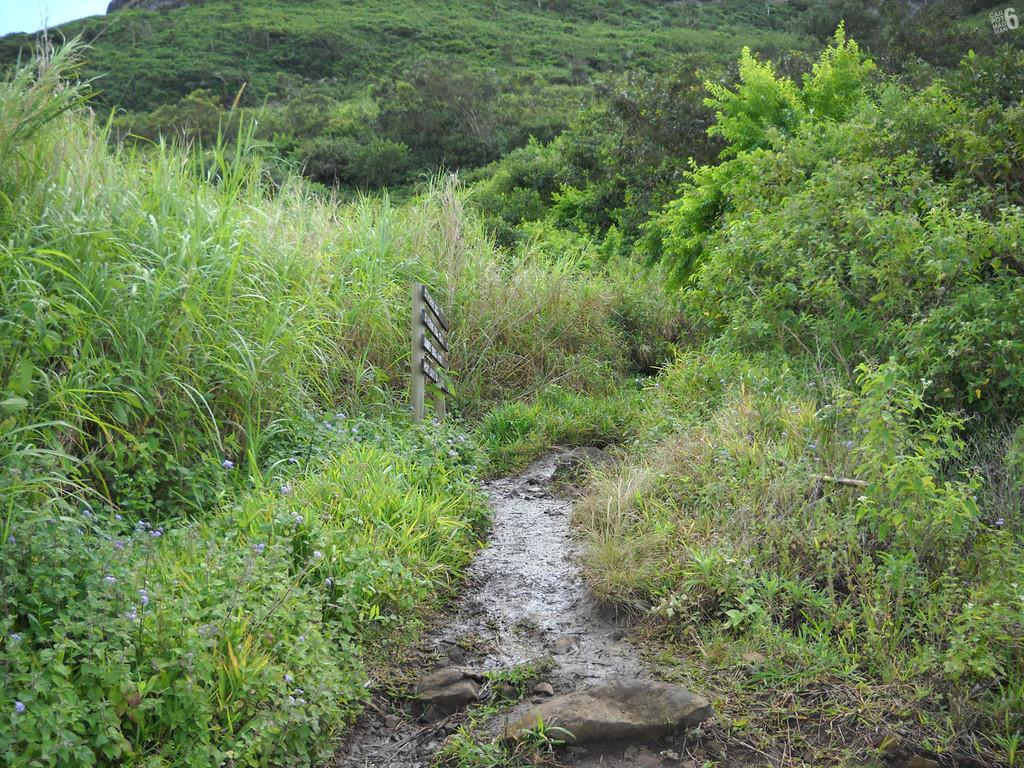What type of vegetation can be seen in the image? There are plants, grass, and trees in the image. What type of ground surface is visible in the image? Stones are present in the image. What structures are on poles in the image? Boards are on poles in the image. What part of the natural environment is visible in the image? The sky is visible in the top left corner of the image. What type of cabbage is the woman holding in the image? There is no woman or cabbage present in the image. What sound does the bell make in the image? There is no bell present in the image. 